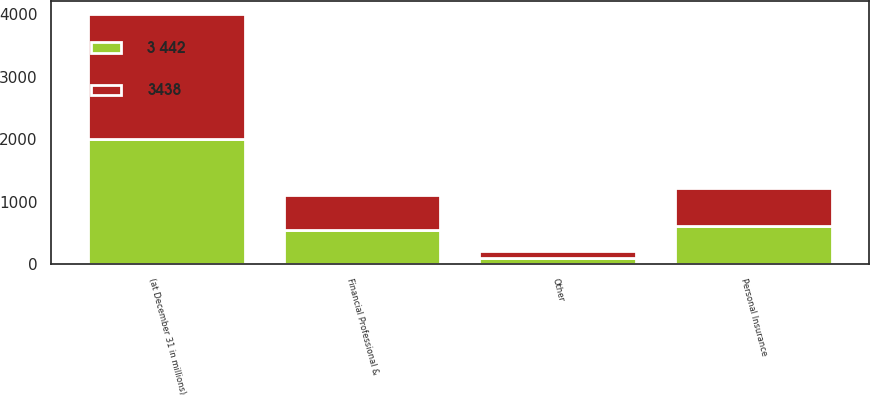Convert chart to OTSL. <chart><loc_0><loc_0><loc_500><loc_500><stacked_bar_chart><ecel><fcel>(at December 31 in millions)<fcel>Financial Professional &<fcel>Personal Insurance<fcel>Other<nl><fcel>3438<fcel>2006<fcel>551<fcel>613<fcel>106<nl><fcel>3 442<fcel>2005<fcel>554<fcel>613<fcel>107<nl></chart> 